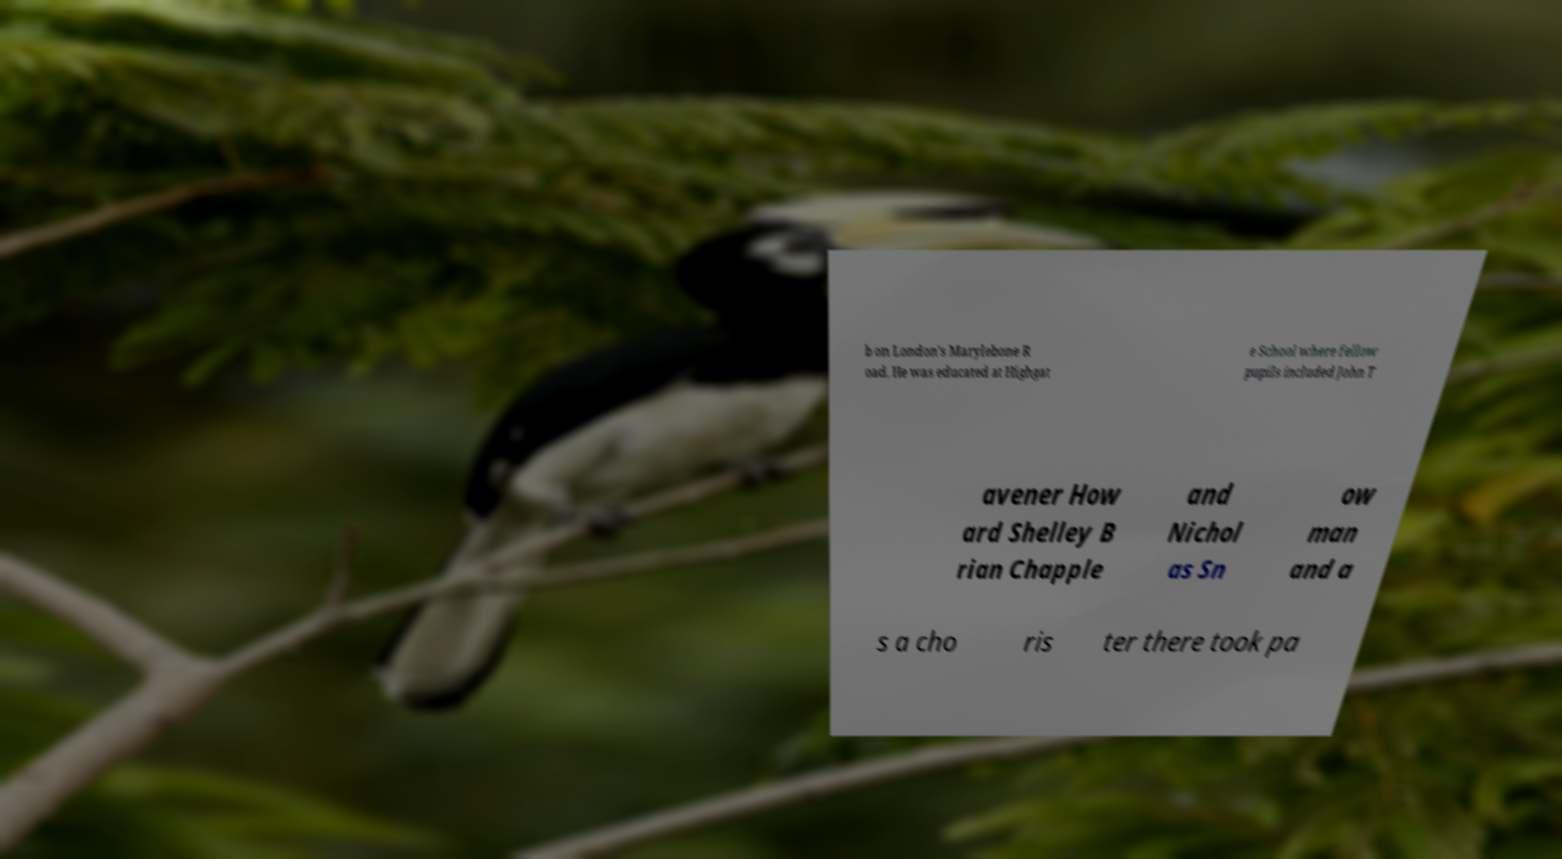Could you assist in decoding the text presented in this image and type it out clearly? b on London's Marylebone R oad. He was educated at Highgat e School where fellow pupils included John T avener How ard Shelley B rian Chapple and Nichol as Sn ow man and a s a cho ris ter there took pa 